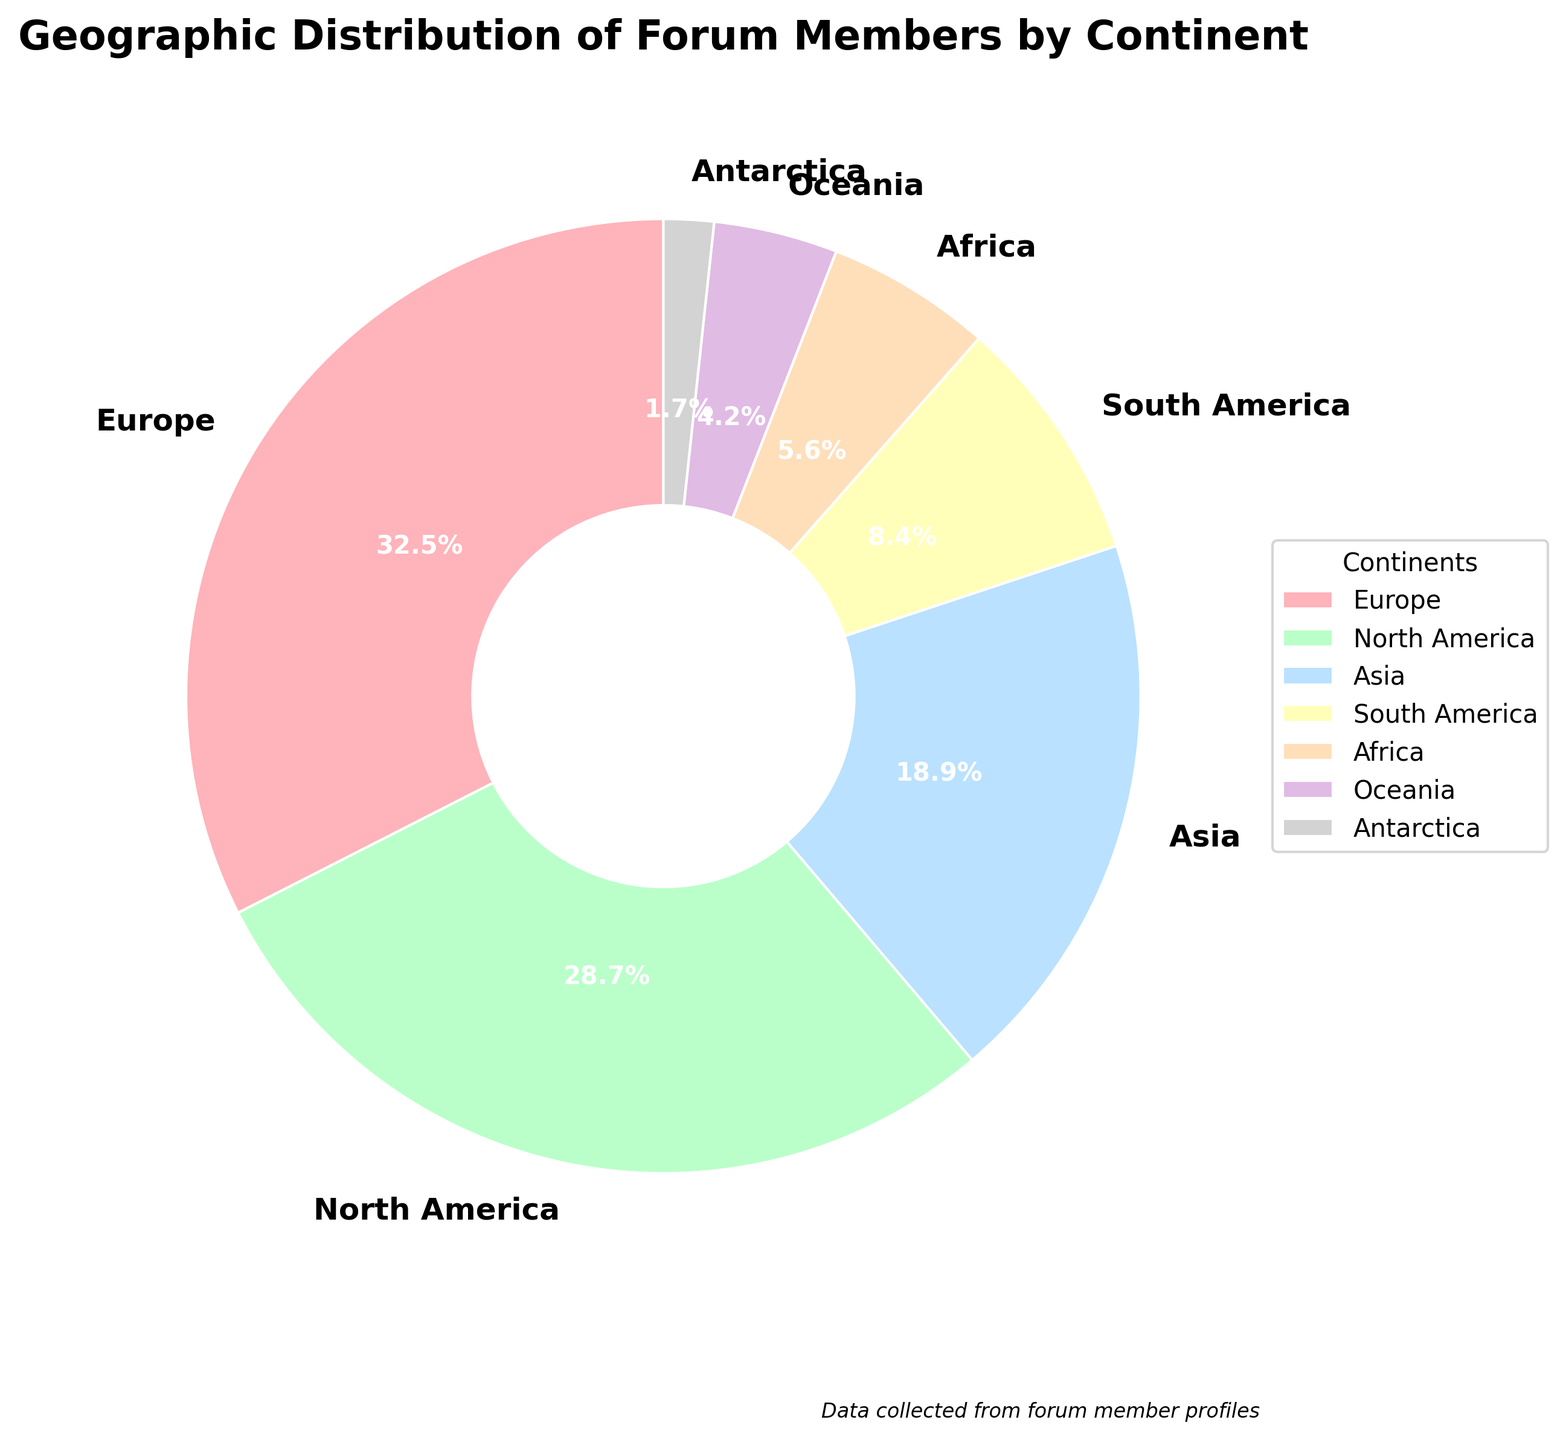What's the sum of percentages of forum members from Europe and North America? To find the sum, add the percentage of members from Europe (32.5%) and the percentage from North America (28.7%). 32.5 + 28.7 = 61.2
Answer: 61.2 Which continent has the smallest percentage of forum members? Look at the pie chart and identify the continent with the smallest segment. The smallest segment corresponds to Antarctica, which has 1.7%.
Answer: Antarctica What is the difference in the percentage of forum members between Asia and South America? Subtract the percentage of forum members from South America (8.4%) from the percentage from Asia (18.9%). 18.9 - 8.4 = 10.5
Answer: 10.5 Which continent's segment is depicted in green in the pie chart? Refer to the color used in the pie chart. The segment in green represents North America.
Answer: North America What is the combined percentage of forum members from continents other than Europe and North America? Subtract the combined percentage of Europe and North America (61.2%) from 100%. 100 - 61.2 = 38.8
Answer: 38.8 Is Oceania's percentage of forum members greater than Africa's? Compare the percentage values: Oceania (4.2%) and Africa (5.6%). Since 4.2 is less than 5.6, Oceania's percentage is not greater.
Answer: No What’s the total percentage of forum members from the Americas (North America and South America)? Add the percentages of North America (28.7%) and South America (8.4%). 28.7 + 8.4 = 37.1
Answer: 37.1 Which continent has the second highest percentage of forum members? Identify the continent with the second largest segment in the pie chart. North America's percentage of 28.7% is the second highest.
Answer: North America 